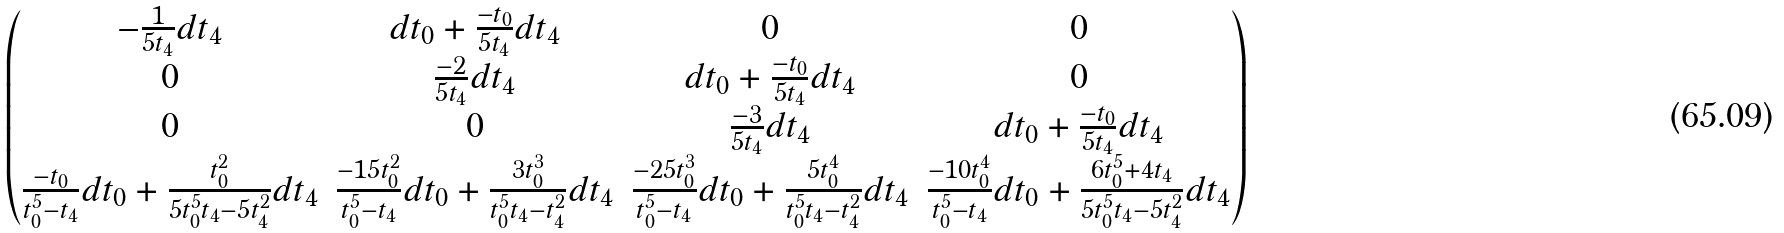<formula> <loc_0><loc_0><loc_500><loc_500>\begin{pmatrix} - \frac { 1 } { 5 t _ { 4 } } d t _ { 4 } & d t _ { 0 } + \frac { - t _ { 0 } } { 5 t _ { 4 } } d t _ { 4 } & 0 & 0 \\ 0 & \frac { - 2 } { 5 t _ { 4 } } d t _ { 4 } & d t _ { 0 } + \frac { - t _ { 0 } } { 5 t _ { 4 } } d t _ { 4 } & 0 \\ 0 & 0 & \frac { - 3 } { 5 t _ { 4 } } d t _ { 4 } & d t _ { 0 } + \frac { - t _ { 0 } } { 5 t _ { 4 } } d t _ { 4 } \\ \frac { - t _ { 0 } } { t _ { 0 } ^ { 5 } - t _ { 4 } } d t _ { 0 } + \frac { t _ { 0 } ^ { 2 } } { 5 t _ { 0 } ^ { 5 } t _ { 4 } - 5 t _ { 4 } ^ { 2 } } d t _ { 4 } & \frac { - 1 5 t _ { 0 } ^ { 2 } } { t _ { 0 } ^ { 5 } - t _ { 4 } } d t _ { 0 } + \frac { 3 t _ { 0 } ^ { 3 } } { t _ { 0 } ^ { 5 } t _ { 4 } - t _ { 4 } ^ { 2 } } d t _ { 4 } & \frac { - 2 5 t _ { 0 } ^ { 3 } } { t _ { 0 } ^ { 5 } - t _ { 4 } } d t _ { 0 } + \frac { 5 t _ { 0 } ^ { 4 } } { t _ { 0 } ^ { 5 } t _ { 4 } - t _ { 4 } ^ { 2 } } d t _ { 4 } & \frac { - 1 0 t _ { 0 } ^ { 4 } } { t _ { 0 } ^ { 5 } - t _ { 4 } } d t _ { 0 } + \frac { 6 t _ { 0 } ^ { 5 } + 4 t _ { 4 } } { 5 t _ { 0 } ^ { 5 } t _ { 4 } - 5 t _ { 4 } ^ { 2 } } d t _ { 4 } \end{pmatrix}</formula> 